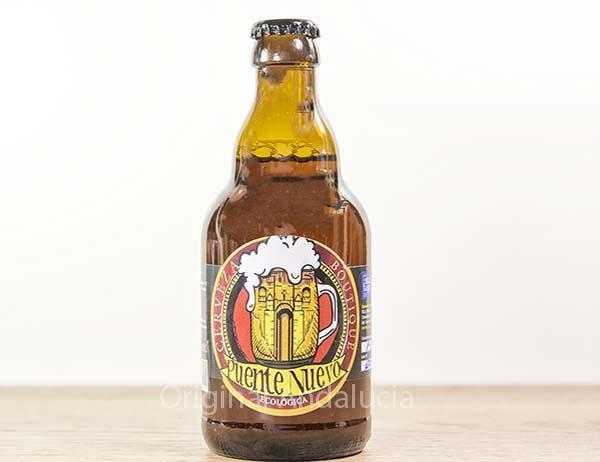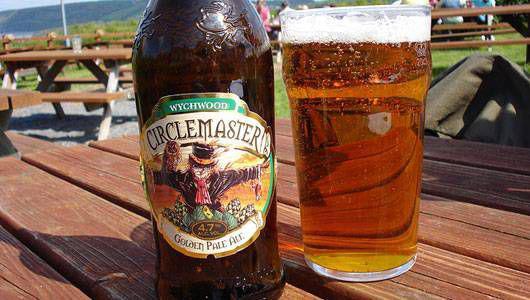The first image is the image on the left, the second image is the image on the right. Assess this claim about the two images: "There are more than ten bottles in total.". Correct or not? Answer yes or no. No. 